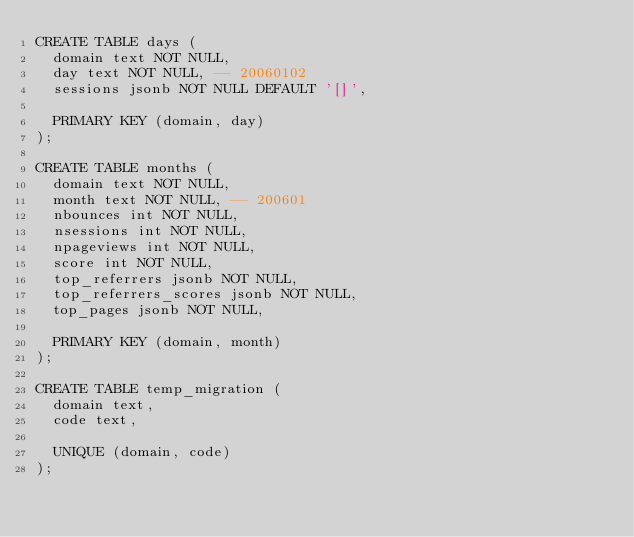Convert code to text. <code><loc_0><loc_0><loc_500><loc_500><_SQL_>CREATE TABLE days (
  domain text NOT NULL,
  day text NOT NULL, -- 20060102
  sessions jsonb NOT NULL DEFAULT '[]',

  PRIMARY KEY (domain, day)
);

CREATE TABLE months (
  domain text NOT NULL,
  month text NOT NULL, -- 200601
  nbounces int NOT NULL,
  nsessions int NOT NULL,
  npageviews int NOT NULL,
  score int NOT NULL,
  top_referrers jsonb NOT NULL,
  top_referrers_scores jsonb NOT NULL,
  top_pages jsonb NOT NULL,

  PRIMARY KEY (domain, month)
);

CREATE TABLE temp_migration (
  domain text,
  code text,

  UNIQUE (domain, code)
);
</code> 